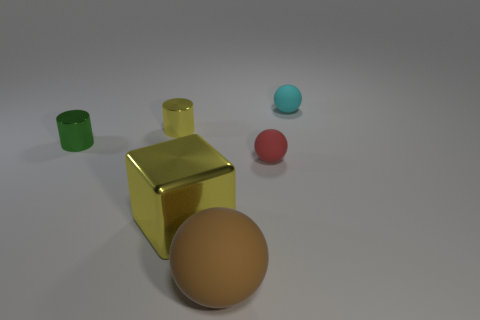Add 3 small metal cylinders. How many objects exist? 9 Subtract all cubes. How many objects are left? 5 Add 6 tiny balls. How many tiny balls are left? 8 Add 3 green shiny cylinders. How many green shiny cylinders exist? 4 Subtract 0 purple cubes. How many objects are left? 6 Subtract all metallic blocks. Subtract all large rubber spheres. How many objects are left? 4 